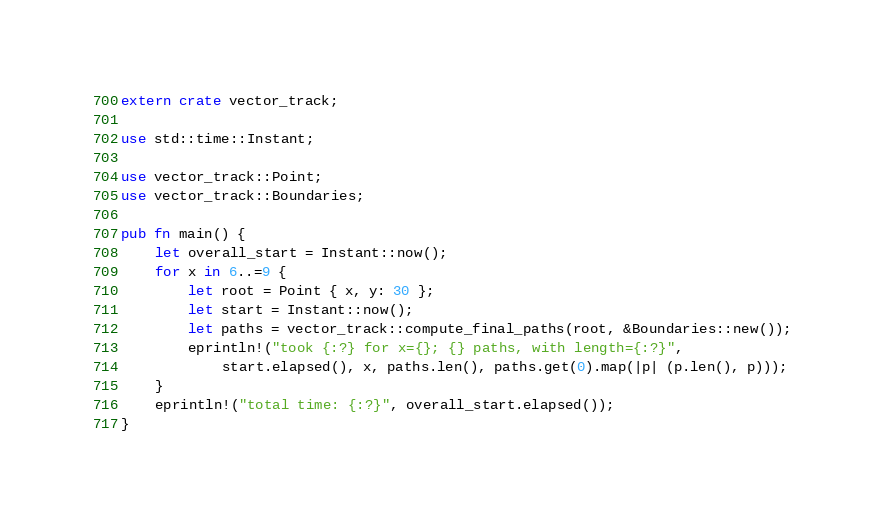Convert code to text. <code><loc_0><loc_0><loc_500><loc_500><_Rust_>extern crate vector_track;

use std::time::Instant;

use vector_track::Point;
use vector_track::Boundaries;

pub fn main() {
    let overall_start = Instant::now();
    for x in 6..=9 {
        let root = Point { x, y: 30 };
        let start = Instant::now();
        let paths = vector_track::compute_final_paths(root, &Boundaries::new());
        eprintln!("took {:?} for x={}; {} paths, with length={:?}",
            start.elapsed(), x, paths.len(), paths.get(0).map(|p| (p.len(), p)));
    }
    eprintln!("total time: {:?}", overall_start.elapsed());
}
</code> 